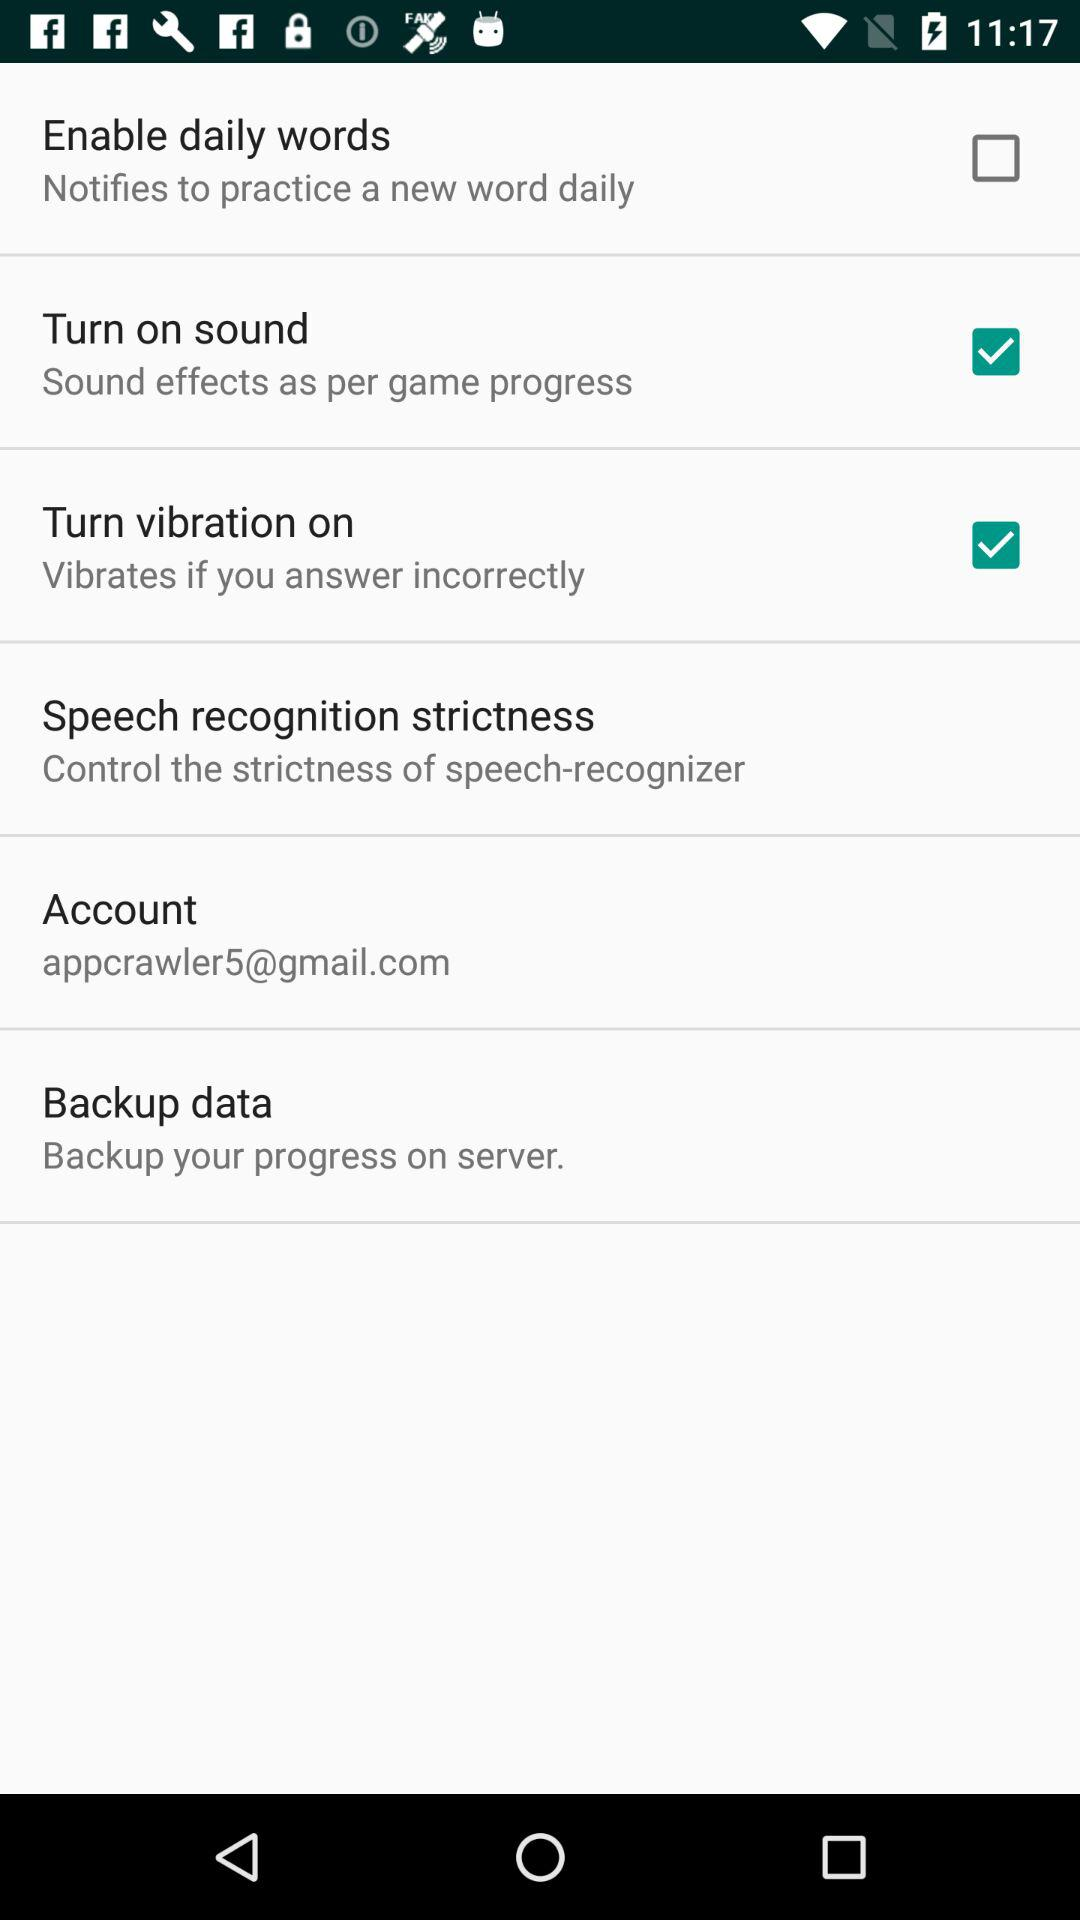What is the status of "turn on sound"? The status of "turn on sound" is on. 